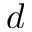Convert formula to latex. <formula><loc_0><loc_0><loc_500><loc_500>d</formula> 